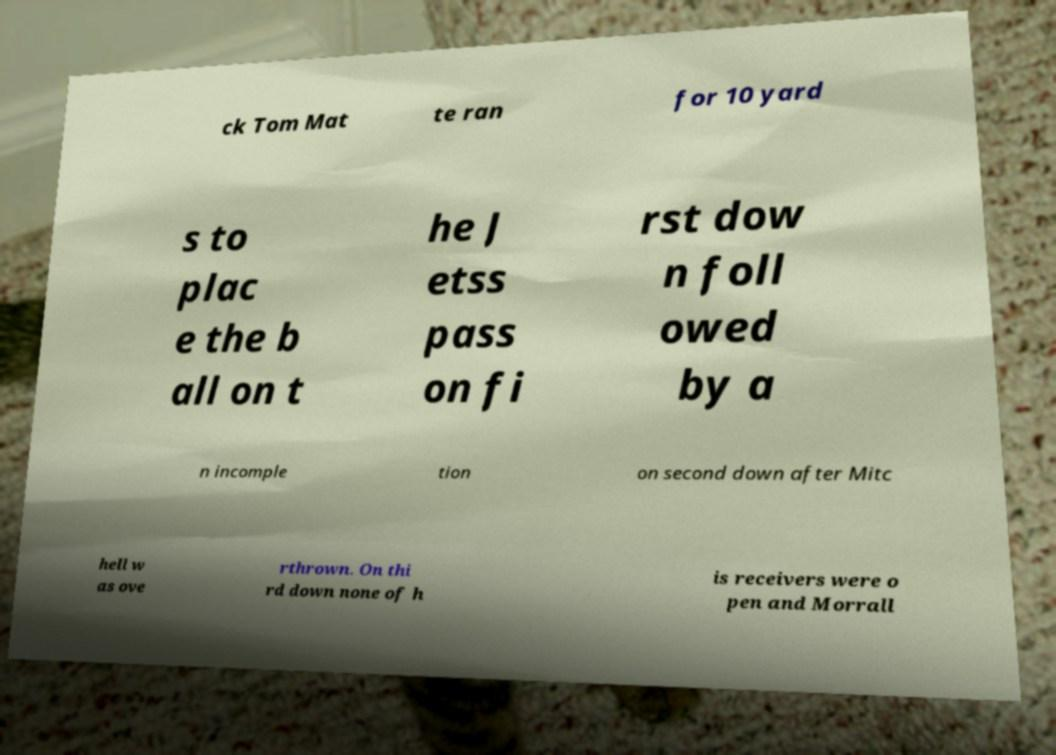For documentation purposes, I need the text within this image transcribed. Could you provide that? ck Tom Mat te ran for 10 yard s to plac e the b all on t he J etss pass on fi rst dow n foll owed by a n incomple tion on second down after Mitc hell w as ove rthrown. On thi rd down none of h is receivers were o pen and Morrall 